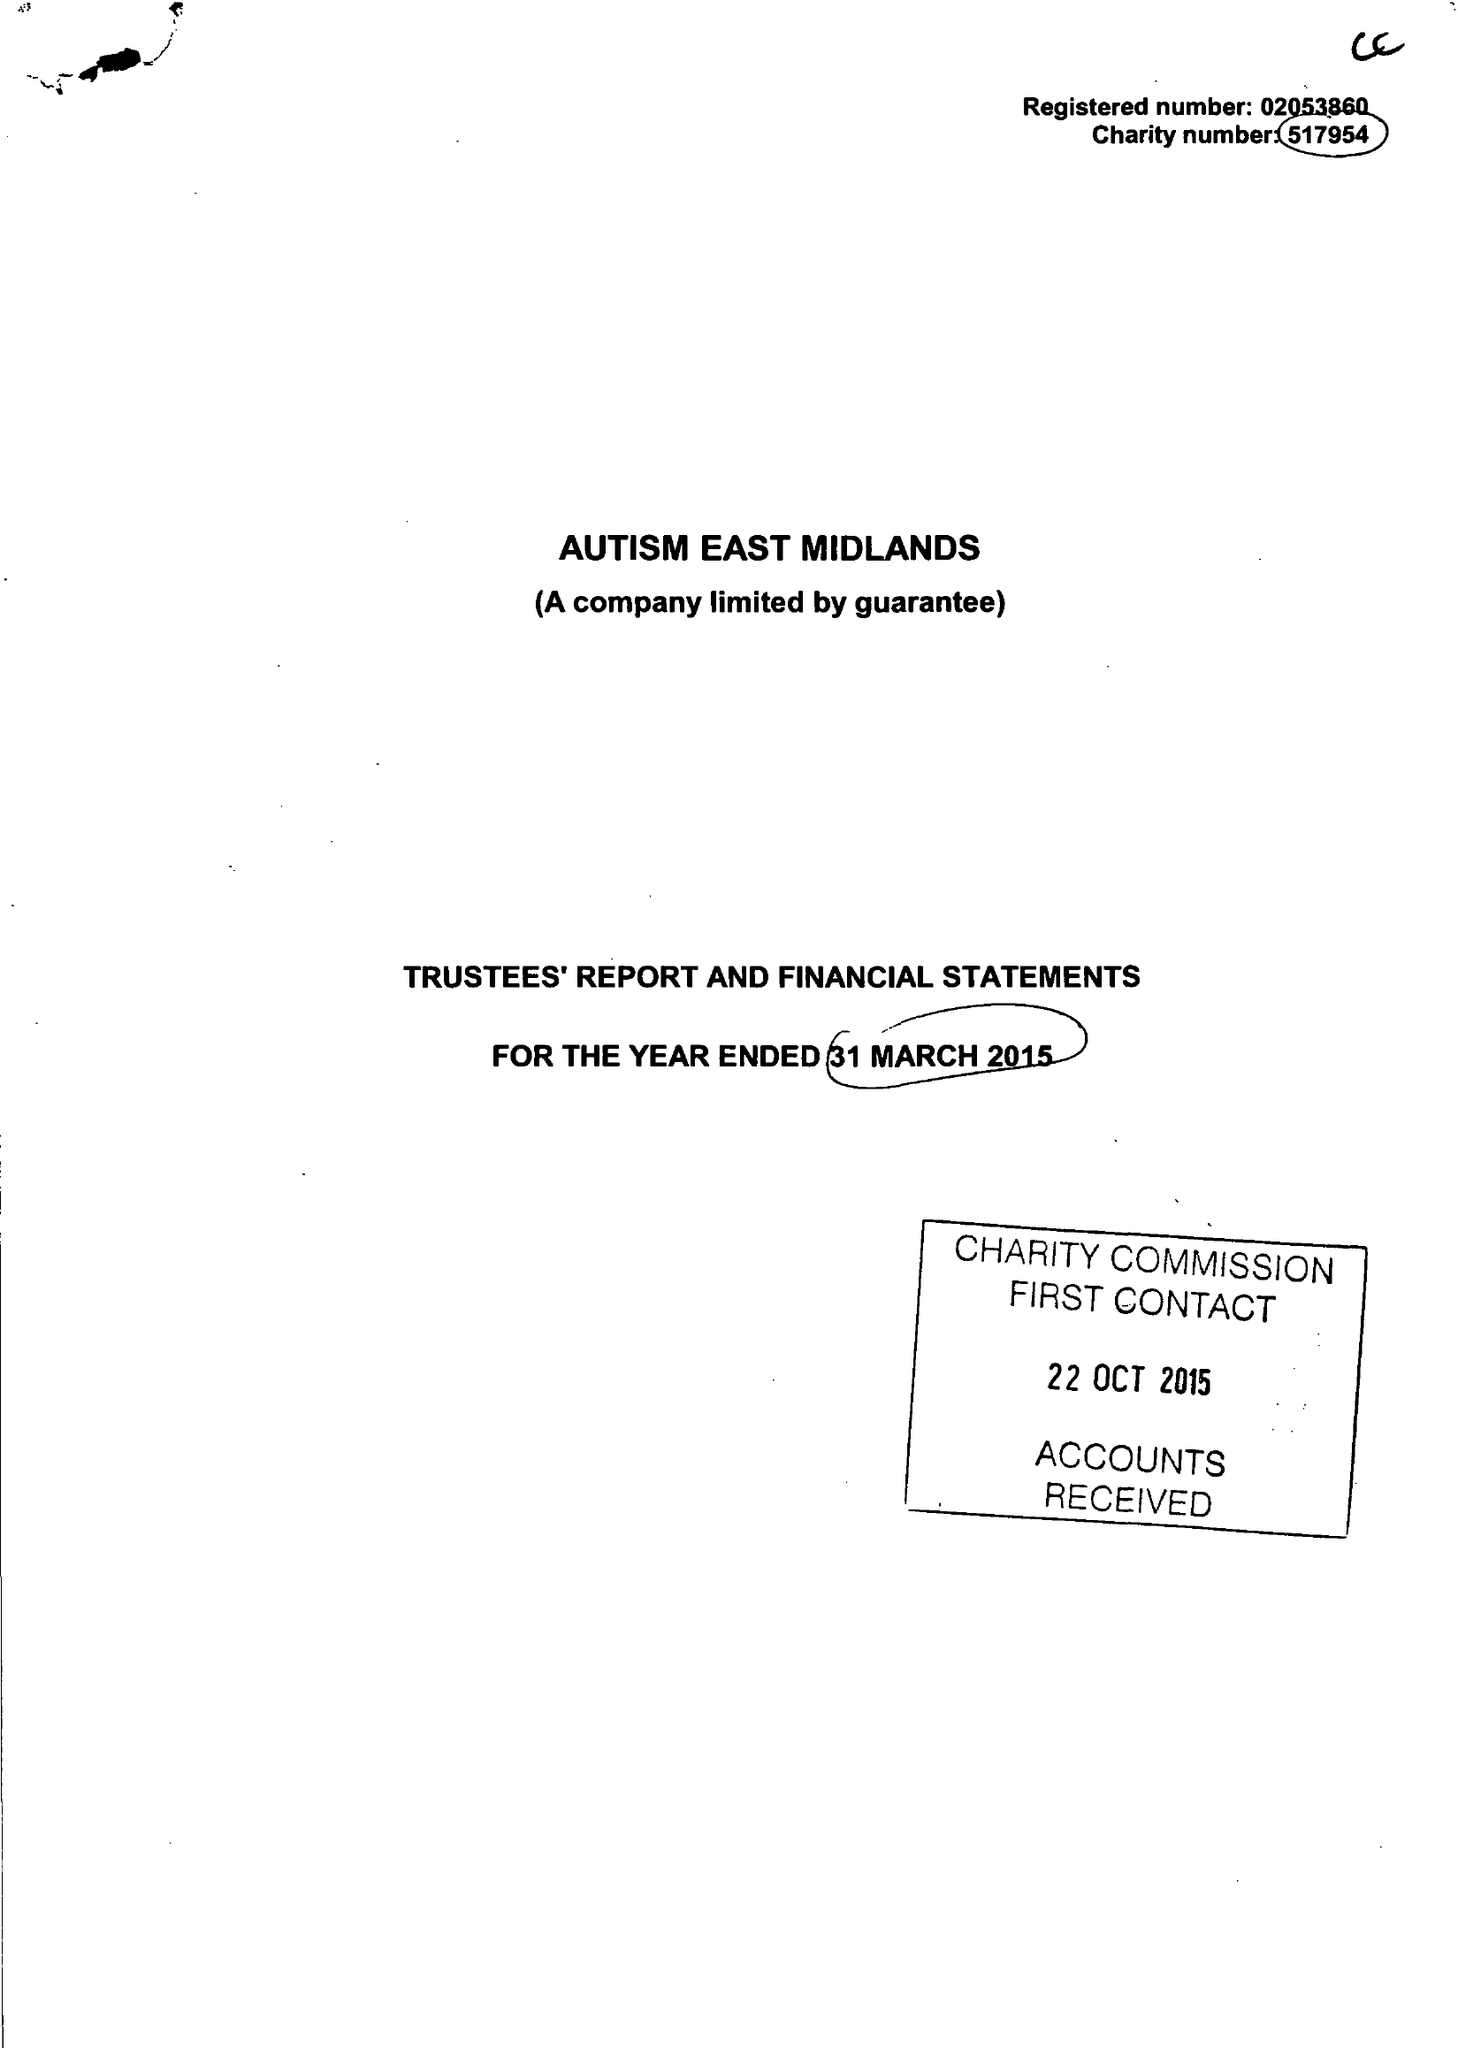What is the value for the spending_annually_in_british_pounds?
Answer the question using a single word or phrase. 11874775.00 